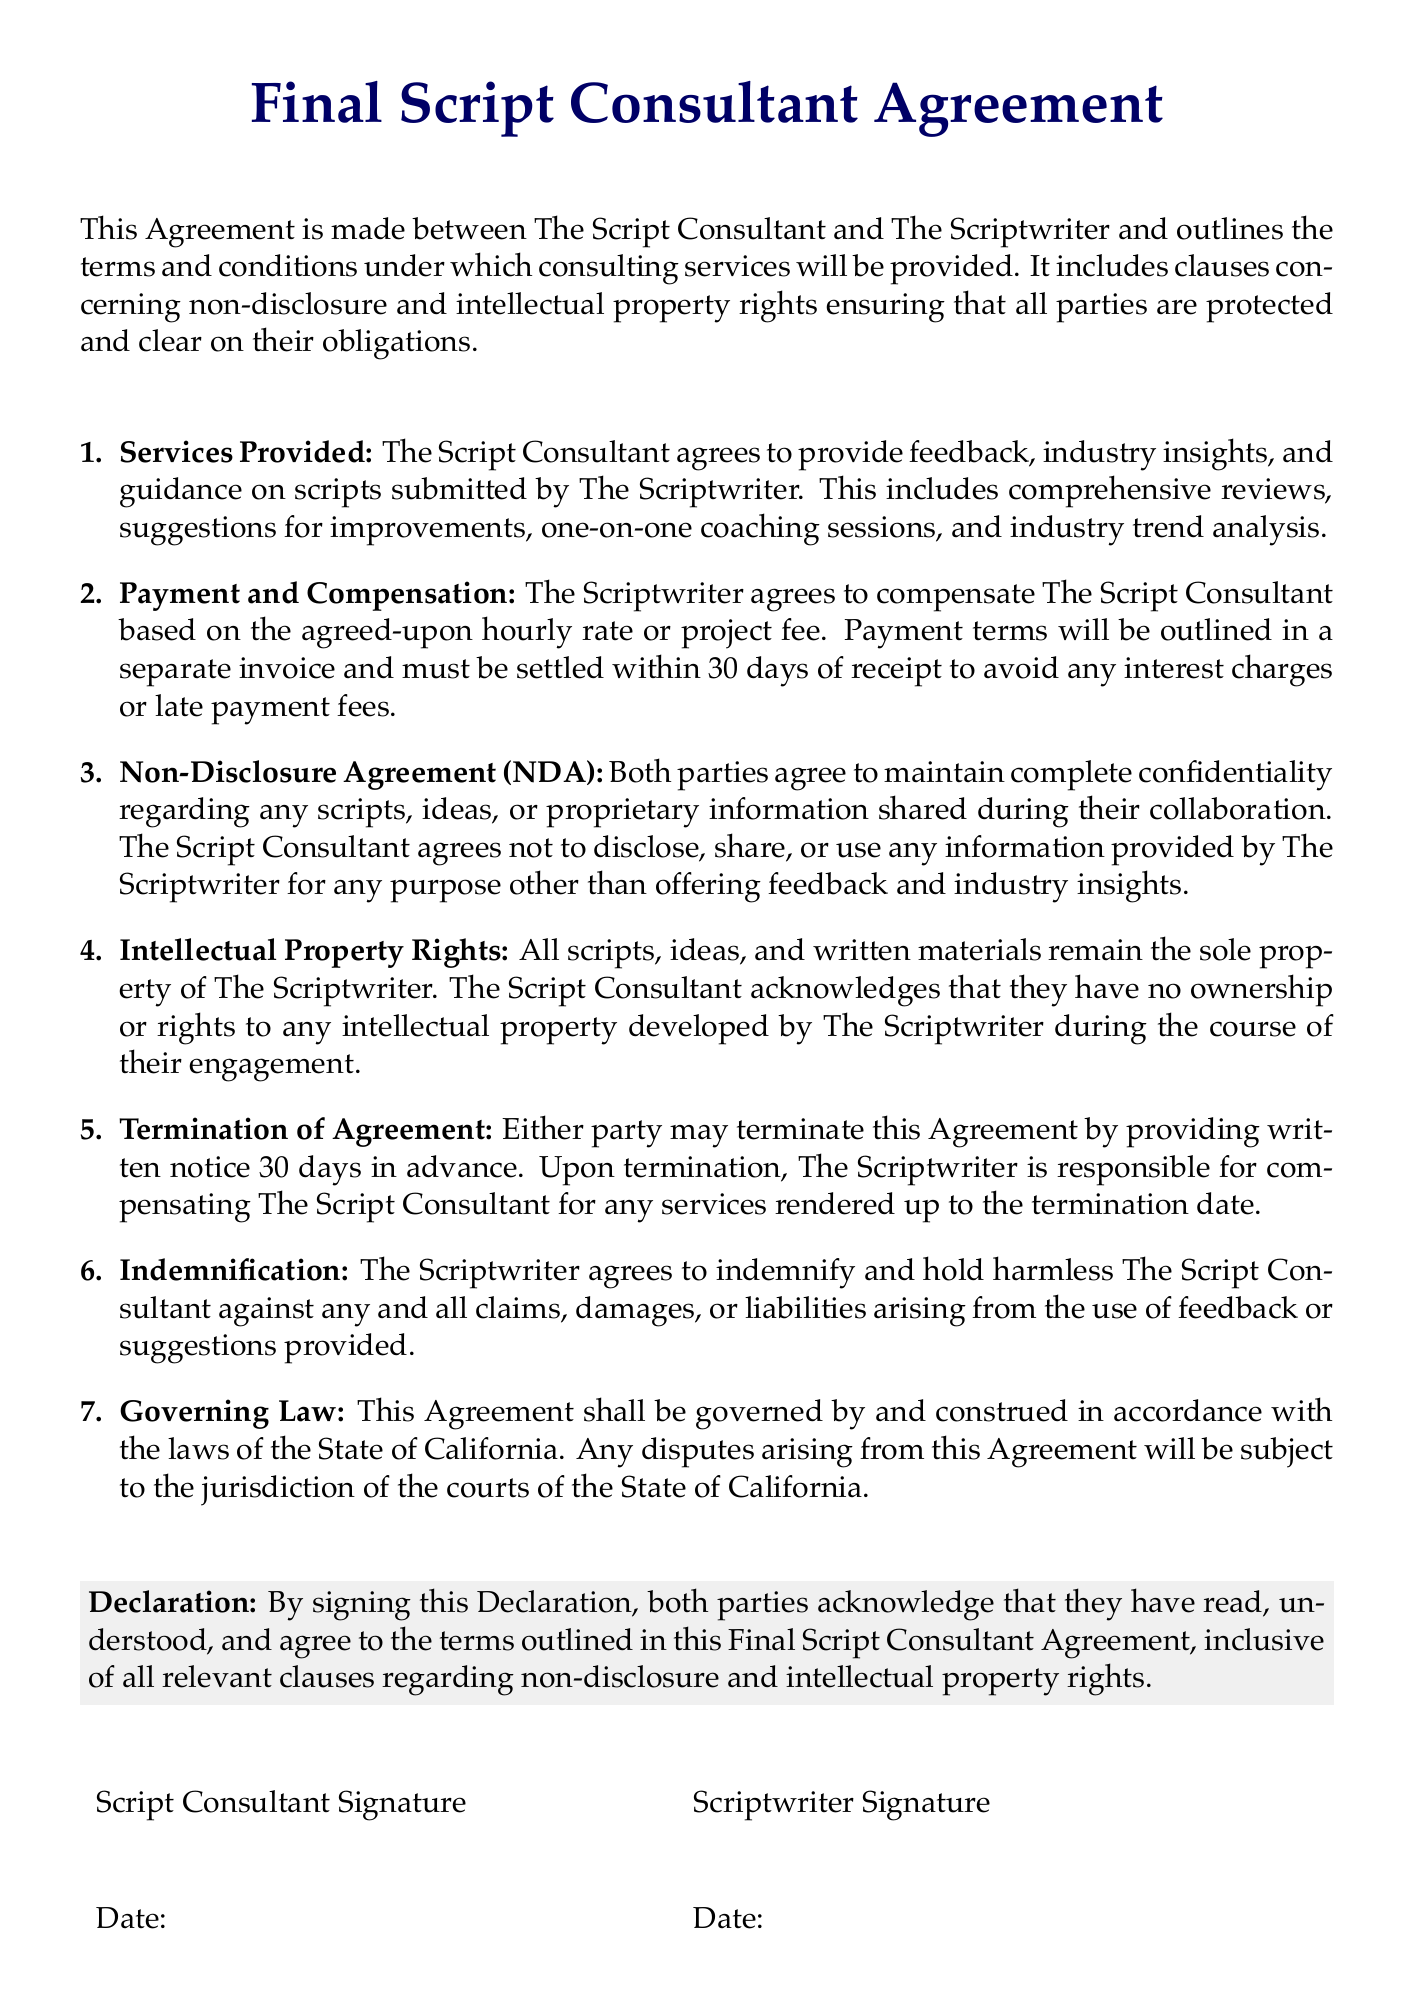What is the title of the document? The title is the main heading of the document, which is prominently displayed at the top.
Answer: Final Script Consultant Agreement Who are the parties involved in the agreement? The parties are mentioned in the introductory sentence of the document.
Answer: The Script Consultant and The Scriptwriter How many days does the Scriptwriter have to settle payment? The payment terms specify a timeframe for compensation after receiving the invoice.
Answer: 30 days What is the governing law mentioned in the agreement? The section on governing law specifies which state's law applies to the document.
Answer: State of California What must both parties agree to maintain? This refers to an important obligation laid out in the non-disclosure clause.
Answer: Complete confidentiality What is acknowledged by both parties in the Declaration? The Declaration outlines what both parties confirm regarding their understanding of the agreement.
Answer: They have read, understood, and agree to the terms How many days’ notice is required for termination of the agreement? The section on termination outlines the necessary notice period to end the collaboration.
Answer: 30 days What does the Scriptwriter agree to do regarding claims against the Consultant? This is stated in the indemnification clause of the document.
Answer: Indemnify and hold harmless 